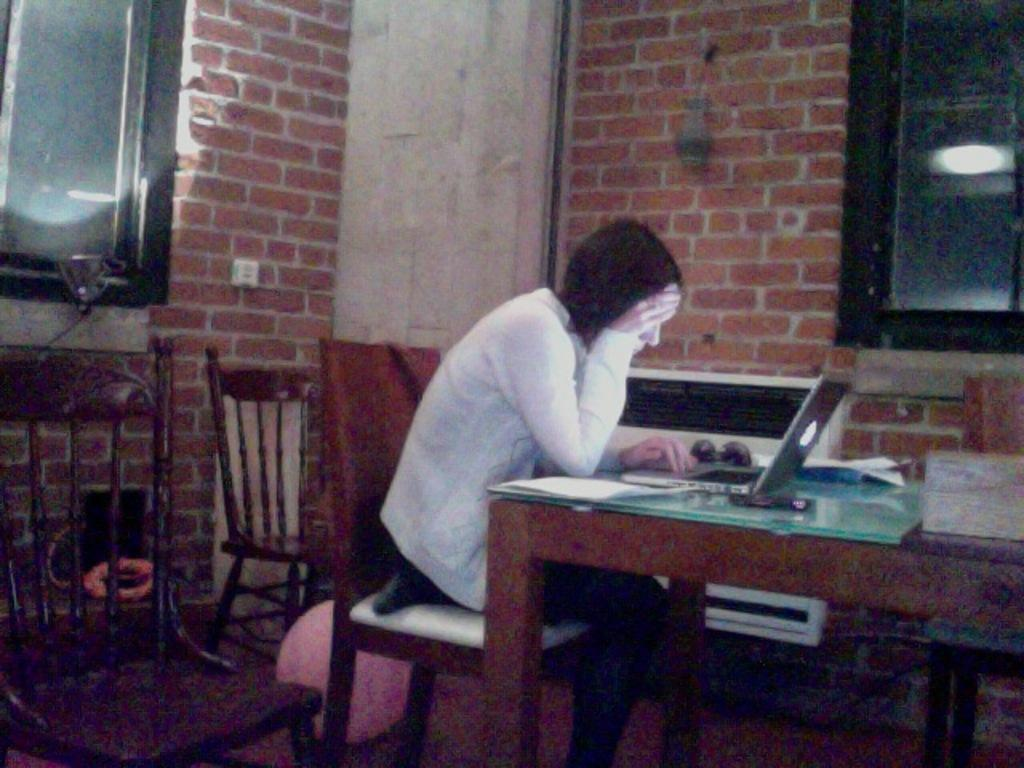Who is the main subject in the image? There is a lady in the image. What is the lady wearing? The lady is wearing a white jacket. What is the lady doing in the image? The lady is sitting on a chair. Where is the chair located in relation to the table? The chair is in front of a table. What can be seen on the table? There is a system on the table. What type of porter is serving the lady in the image? There is no porter present in the image, and the lady is not being served by anyone. 